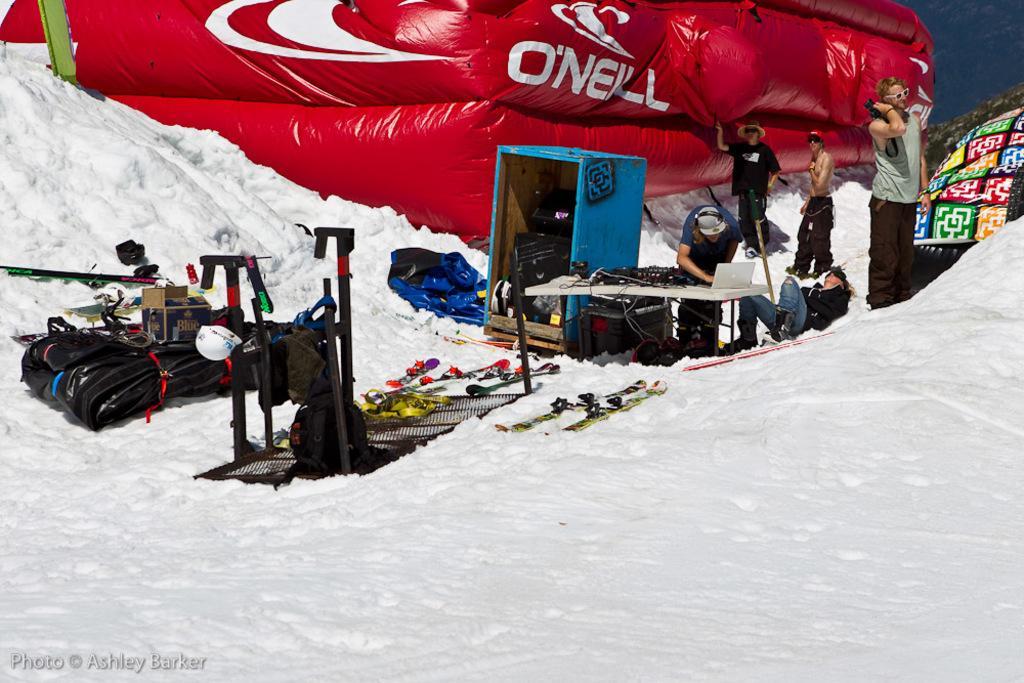Describe this image in one or two sentences. In the foreground of the image we can see group of objects, skis and a container placed on the snow. To the right side of the image we can see laptop placed on a table, a group of persons standing. One woman is lying on the snow. In the background, we can see a balloon, a cloth, hill and the sky. 